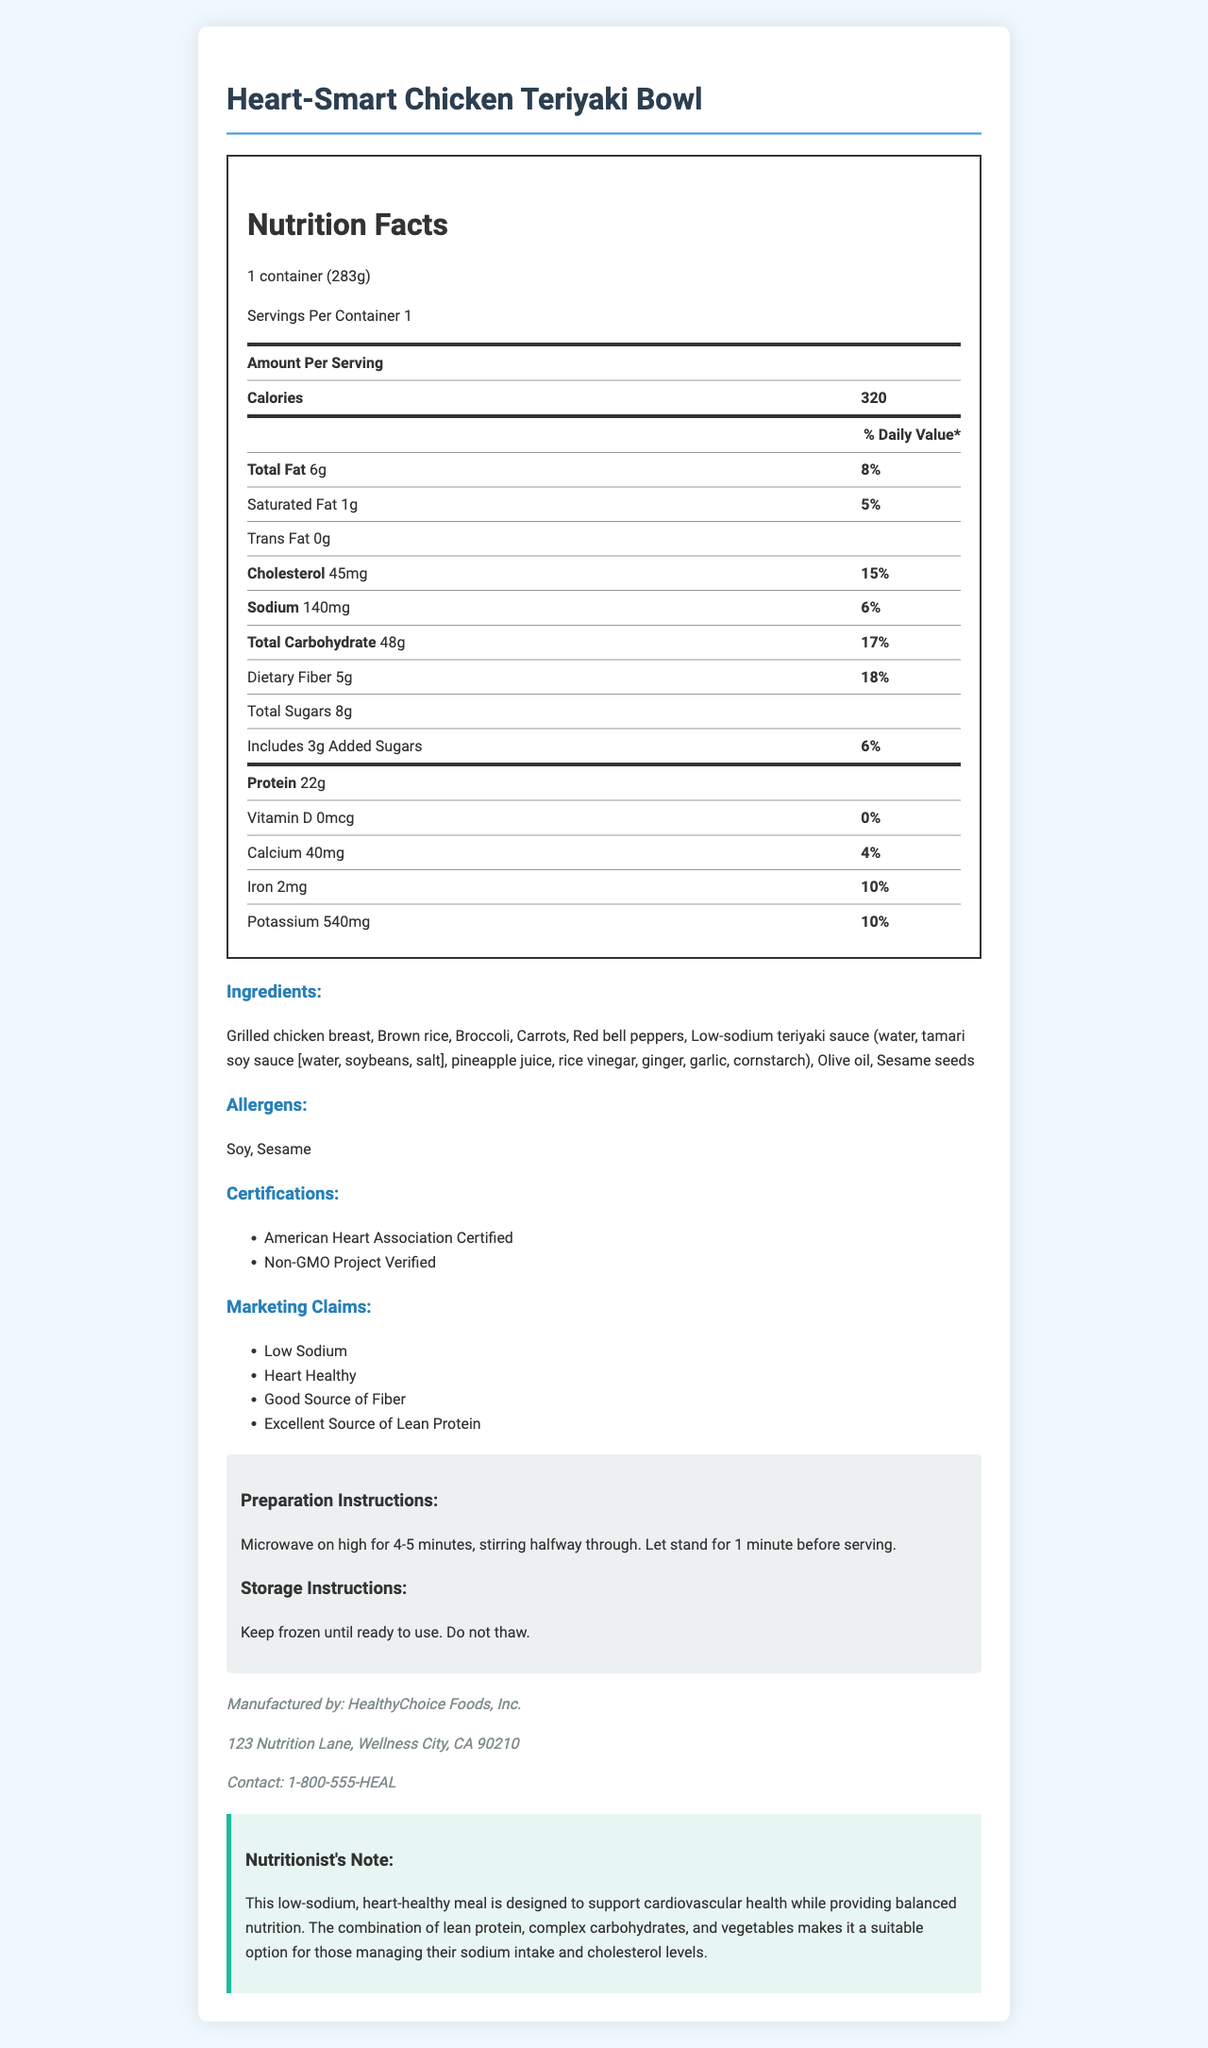what is the serving size of the Heart-Smart Chicken Teriyaki Bowl? The serving size is listed as "1 container (283g)" at the top of the nutrition facts section.
Answer: 1 container (283g) How many grams of dietary fiber does one serving of this meal contain? The amount of dietary fiber per serving is listed as 5 grams in the nutrition facts section.
Answer: 5 grams What percentage of the daily value for iron does one serving of this meal provide? The daily value percentage for iron is shown as 10% in the nutrition facts section.
Answer: 10% Is this meal a good source of lean protein? The meal is marked with the marketing claim "Excellent Source of Lean Protein."
Answer: Yes What is the amount of total sugars in one serving of this meal? The total sugars content per serving is listed as 8 grams in the nutrition facts section.
Answer: 8 grams How much calcium does this meal contain? The calcium content is listed as 40 milligrams in the nutrition facts section.
Answer: 40 milligrams What is the preparation time for the Heart-Smart Chicken Teriyaki Bowl? A. 2-3 minutes B. 4-5 minutes C. 6-7 minutes D. 8-10 minutes The preparation instructions state to "Microwave on high for 4-5 minutes."
Answer: B Which of the following certifications does this product have? I. American Heart Association Certified II. USDA Organic III. Non-GMO Project Verified IV. Gluten-Free The certifications listed are "American Heart Association Certified" and "Non-GMO Project Verified."
Answer: I and III Does this meal contain any trans fat? The amount of trans fat is listed as 0 grams in the nutrition facts section.
Answer: No Summarize the main idea of the document. The document provides comprehensive details about the product, highlighting its health benefits, nutritional value, certifications, and instructions for use and storage.
Answer: The Heart-Smart Chicken Teriyaki Bowl is a low-sodium, heart-healthy frozen dinner. It includes nutritional information, ingredients, allergens, certifications, marketing claims, preparation, and storage instructions. It aims to support cardiovascular health by providing a meal with lean protein, complex carbohydrates, and vegetables. What is the price of the Heart-Smart Chicken Teriyaki Bowl? The document does not provide any information about the price of the product.
Answer: Not enough information 